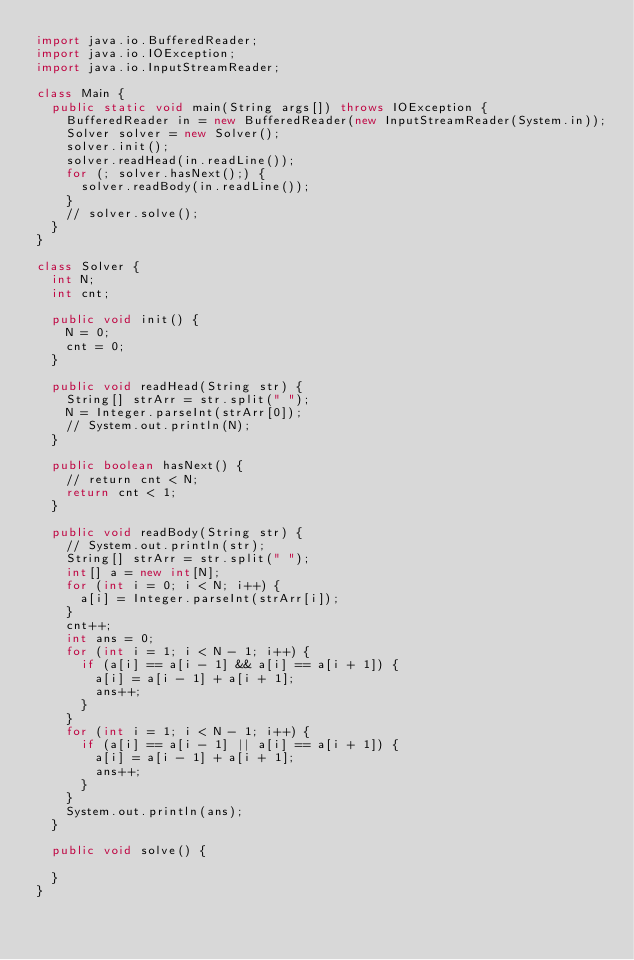Convert code to text. <code><loc_0><loc_0><loc_500><loc_500><_Java_>import java.io.BufferedReader;
import java.io.IOException;
import java.io.InputStreamReader;

class Main {
	public static void main(String args[]) throws IOException {
		BufferedReader in = new BufferedReader(new InputStreamReader(System.in));
		Solver solver = new Solver();
		solver.init();
		solver.readHead(in.readLine());
		for (; solver.hasNext();) {
			solver.readBody(in.readLine());
		}
		// solver.solve();
	}
}

class Solver {
	int N;
	int cnt;

	public void init() {
		N = 0;
		cnt = 0;
	}

	public void readHead(String str) {
		String[] strArr = str.split(" ");
		N = Integer.parseInt(strArr[0]);
		// System.out.println(N);
	}

	public boolean hasNext() {
		// return cnt < N;
		return cnt < 1;
	}

	public void readBody(String str) {
		// System.out.println(str);
		String[] strArr = str.split(" ");
		int[] a = new int[N];
		for (int i = 0; i < N; i++) {
			a[i] = Integer.parseInt(strArr[i]);
		}
		cnt++;
		int ans = 0;
		for (int i = 1; i < N - 1; i++) {
			if (a[i] == a[i - 1] && a[i] == a[i + 1]) {
				a[i] = a[i - 1] + a[i + 1];
				ans++;
			}
		}
		for (int i = 1; i < N - 1; i++) {
			if (a[i] == a[i - 1] || a[i] == a[i + 1]) {
				a[i] = a[i - 1] + a[i + 1];
				ans++;
			}
		}
		System.out.println(ans);
	}

	public void solve() {

	}
}
</code> 